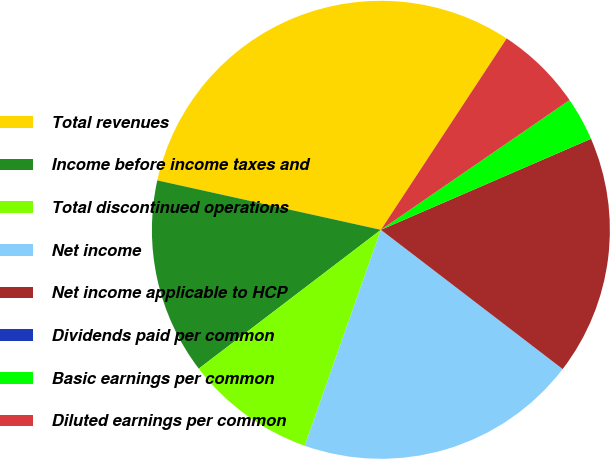<chart> <loc_0><loc_0><loc_500><loc_500><pie_chart><fcel>Total revenues<fcel>Income before income taxes and<fcel>Total discontinued operations<fcel>Net income<fcel>Net income applicable to HCP<fcel>Dividends paid per common<fcel>Basic earnings per common<fcel>Diluted earnings per common<nl><fcel>30.79%<fcel>13.83%<fcel>9.24%<fcel>19.99%<fcel>16.91%<fcel>0.0%<fcel>3.08%<fcel>6.16%<nl></chart> 